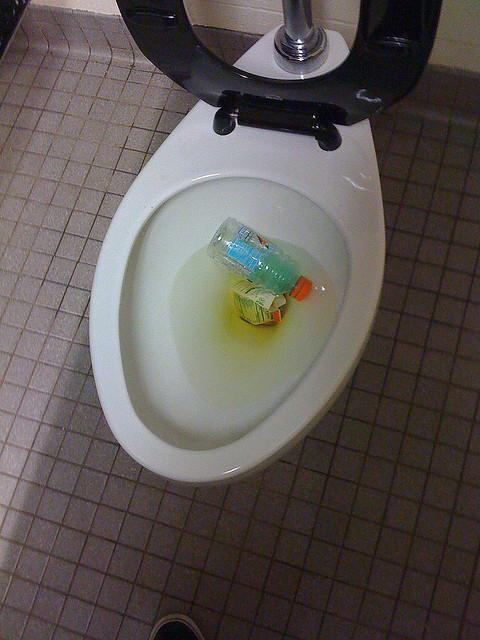How many boats are in the water?
Give a very brief answer. 0. 